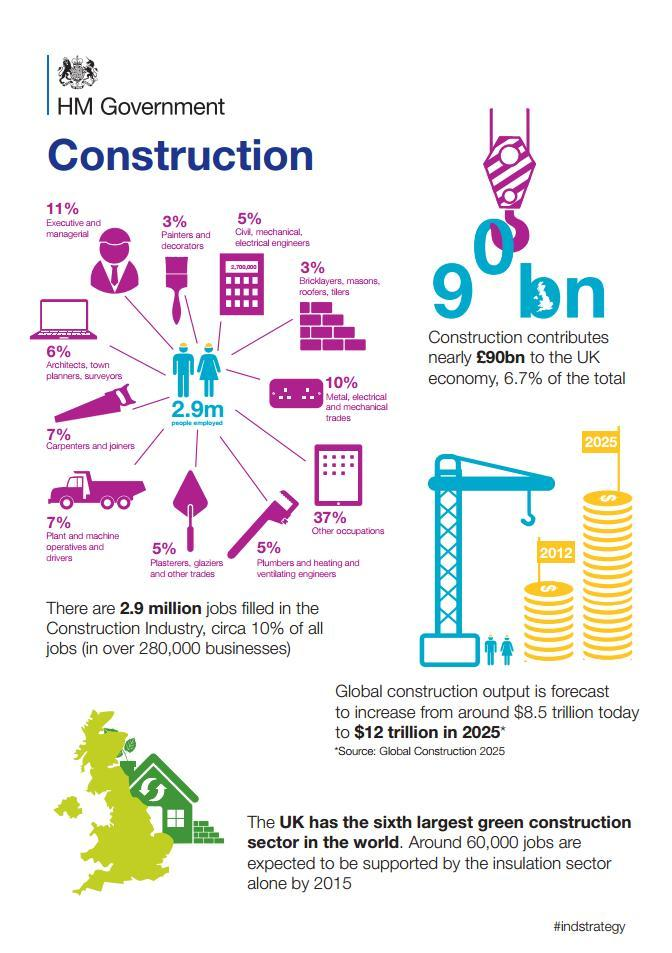What is the percentage of carpenters, joiners, operators and drivers in the construction industry?
Answer the question with a short phrase. 7% What is the percentage of painters and decorators in the construction industry, 11%, 3%, or 5%? 3% What is the total percentage of managerial staff, architects, planners, and surveyors in the construction  industry? 17% 